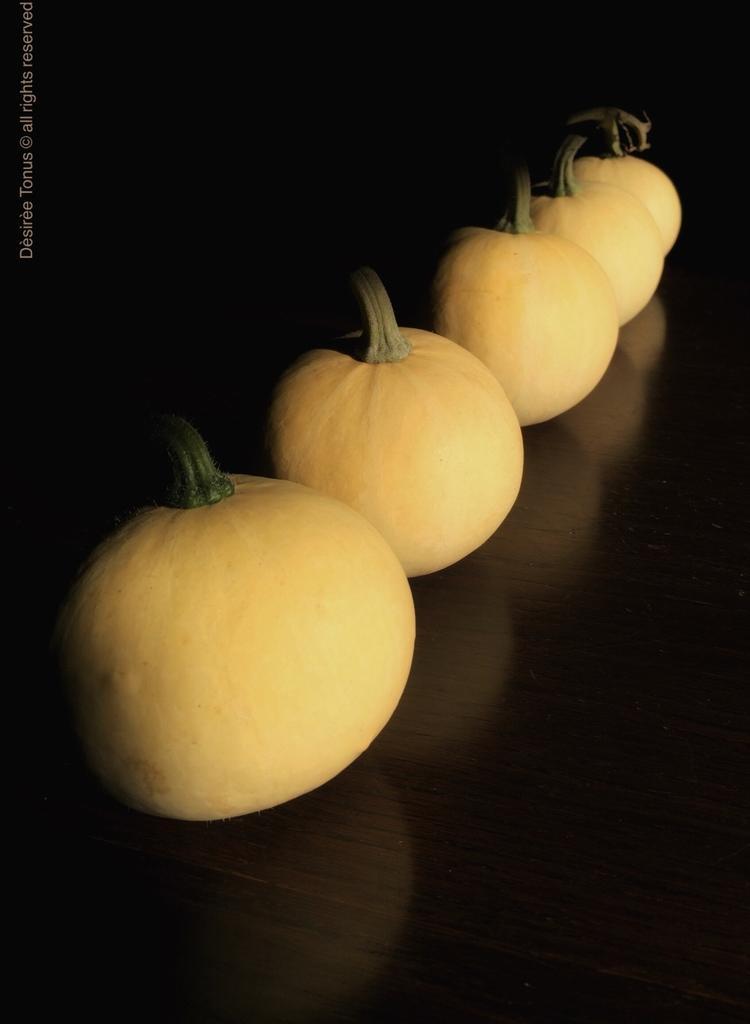How would you summarize this image in a sentence or two? These are the pumpkins. 